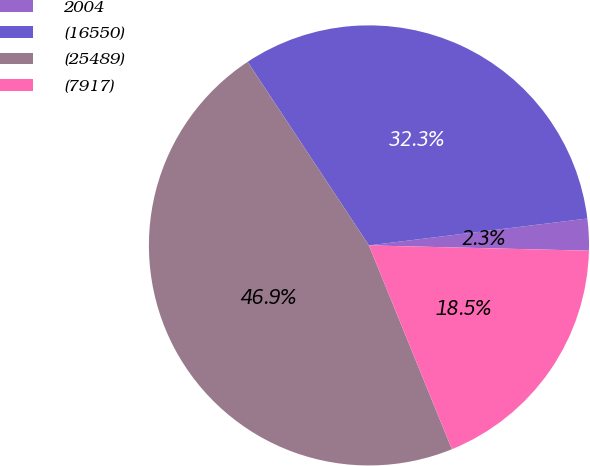Convert chart to OTSL. <chart><loc_0><loc_0><loc_500><loc_500><pie_chart><fcel>2004<fcel>(16550)<fcel>(25489)<fcel>(7917)<nl><fcel>2.33%<fcel>32.35%<fcel>46.86%<fcel>18.47%<nl></chart> 